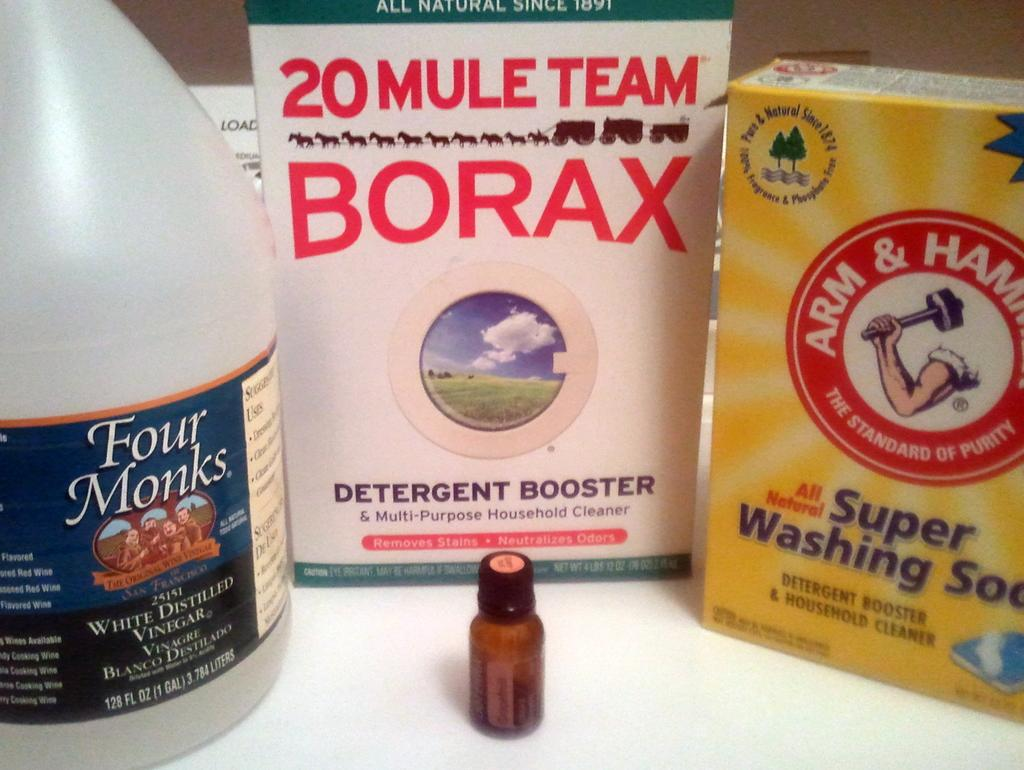<image>
Give a short and clear explanation of the subsequent image. Washing detergent, one of which is from Arm and Hammer. 